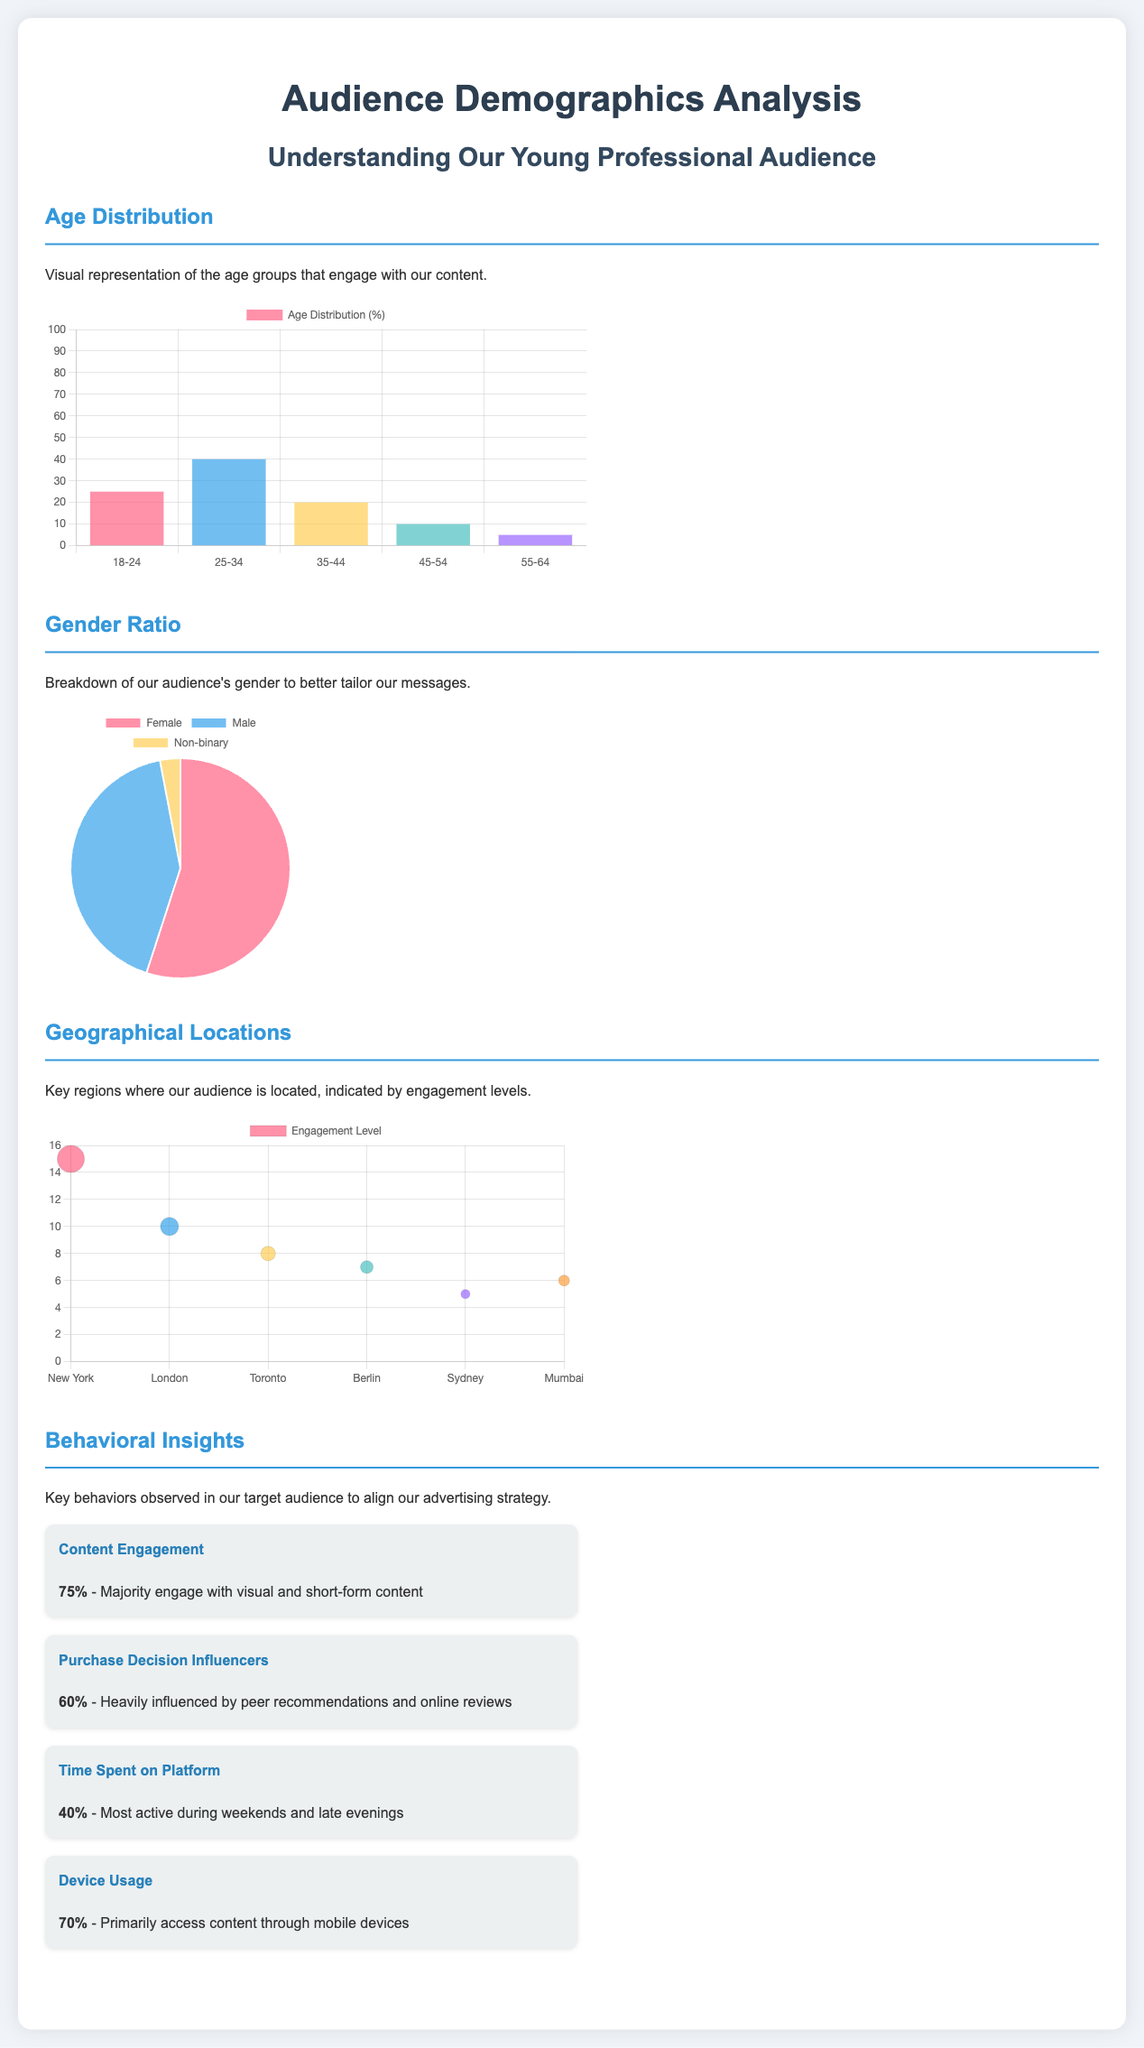What is the percentage of the 25-34 age group? The percentage of the 25-34 age group in the age distribution is specifically represented in the chart, which indicates it as 40%.
Answer: 40% What is the gender ratio for non-binary individuals? The gender ratio pie chart shows that non-binary individuals constitute 3% of the audience.
Answer: 3% What percentage of the audience engages with visual and short-form content? The behavioral insights section highlights that 75% of the audience engages with visual and short-form content.
Answer: 75% Which geographical location has the highest engagement level? The geographical locations chart indicates that New York has the highest engagement level with a value of 15.
Answer: New York What is the influence of peer recommendations on purchase decisions? The insight highlights that 60% of the audience is influenced by peer recommendations and online reviews.
Answer: 60% How many age groups are represented in the document? The age distribution section provides visual representations for five distinct age groups.
Answer: Five During which time are most users most active? The behavioral insights indicate that users are most active during weekends and late evenings.
Answer: Weekends and late evenings What is the primary device used by the audience to access content? The insight states that 70% of the audience primarily access content through mobile devices.
Answer: Mobile devices 